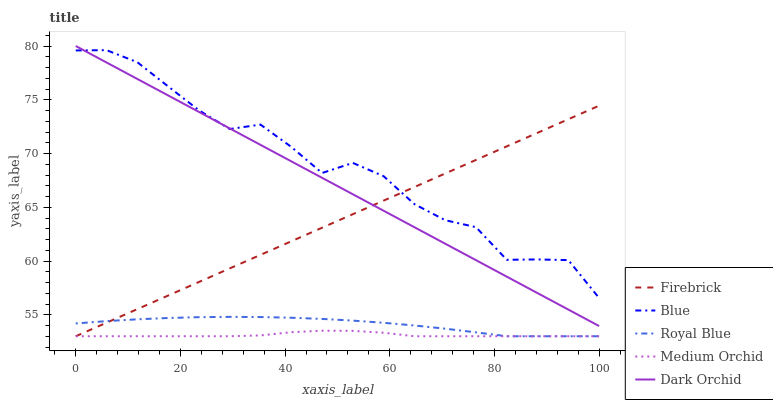Does Medium Orchid have the minimum area under the curve?
Answer yes or no. Yes. Does Blue have the maximum area under the curve?
Answer yes or no. Yes. Does Royal Blue have the minimum area under the curve?
Answer yes or no. No. Does Royal Blue have the maximum area under the curve?
Answer yes or no. No. Is Dark Orchid the smoothest?
Answer yes or no. Yes. Is Blue the roughest?
Answer yes or no. Yes. Is Royal Blue the smoothest?
Answer yes or no. No. Is Royal Blue the roughest?
Answer yes or no. No. Does Royal Blue have the lowest value?
Answer yes or no. Yes. Does Dark Orchid have the lowest value?
Answer yes or no. No. Does Dark Orchid have the highest value?
Answer yes or no. Yes. Does Royal Blue have the highest value?
Answer yes or no. No. Is Medium Orchid less than Blue?
Answer yes or no. Yes. Is Blue greater than Medium Orchid?
Answer yes or no. Yes. Does Firebrick intersect Blue?
Answer yes or no. Yes. Is Firebrick less than Blue?
Answer yes or no. No. Is Firebrick greater than Blue?
Answer yes or no. No. Does Medium Orchid intersect Blue?
Answer yes or no. No. 